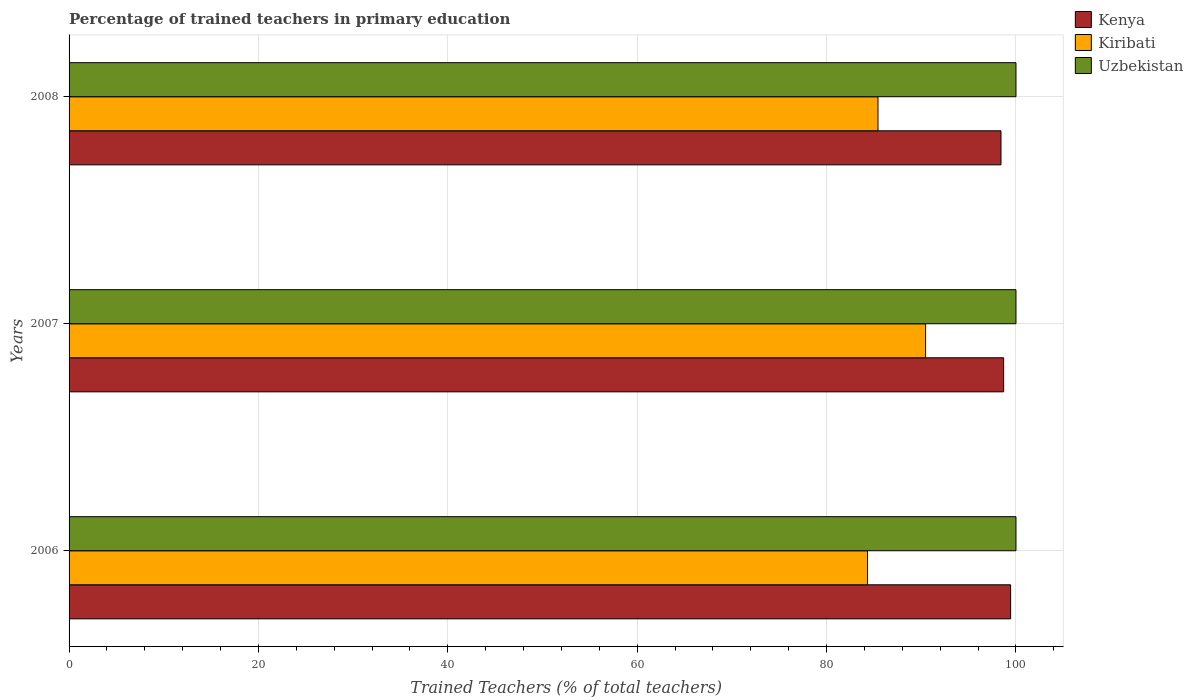Are the number of bars on each tick of the Y-axis equal?
Offer a terse response. Yes. What is the label of the 3rd group of bars from the top?
Offer a terse response. 2006. In how many cases, is the number of bars for a given year not equal to the number of legend labels?
Your answer should be compact. 0. What is the percentage of trained teachers in Kenya in 2006?
Make the answer very short. 99.43. Across all years, what is the minimum percentage of trained teachers in Uzbekistan?
Offer a very short reply. 100. In which year was the percentage of trained teachers in Kenya maximum?
Provide a succinct answer. 2006. In which year was the percentage of trained teachers in Uzbekistan minimum?
Your answer should be compact. 2006. What is the total percentage of trained teachers in Uzbekistan in the graph?
Keep it short and to the point. 300. What is the difference between the percentage of trained teachers in Kiribati in 2006 and the percentage of trained teachers in Uzbekistan in 2008?
Your response must be concise. -15.68. In the year 2007, what is the difference between the percentage of trained teachers in Uzbekistan and percentage of trained teachers in Kiribati?
Your answer should be very brief. 9.55. In how many years, is the percentage of trained teachers in Kiribati greater than 48 %?
Offer a very short reply. 3. What is the ratio of the percentage of trained teachers in Kenya in 2006 to that in 2008?
Provide a succinct answer. 1.01. Is the percentage of trained teachers in Kenya in 2006 less than that in 2008?
Offer a terse response. No. What is the difference between the highest and the second highest percentage of trained teachers in Kiribati?
Provide a short and direct response. 5.03. What is the difference between the highest and the lowest percentage of trained teachers in Uzbekistan?
Provide a short and direct response. 0. What does the 3rd bar from the top in 2008 represents?
Provide a succinct answer. Kenya. What does the 1st bar from the bottom in 2008 represents?
Your response must be concise. Kenya. Is it the case that in every year, the sum of the percentage of trained teachers in Uzbekistan and percentage of trained teachers in Kenya is greater than the percentage of trained teachers in Kiribati?
Your response must be concise. Yes. How many bars are there?
Make the answer very short. 9. Are all the bars in the graph horizontal?
Offer a terse response. Yes. Does the graph contain any zero values?
Offer a very short reply. No. Does the graph contain grids?
Provide a succinct answer. Yes. Where does the legend appear in the graph?
Offer a very short reply. Top right. How many legend labels are there?
Your answer should be compact. 3. How are the legend labels stacked?
Make the answer very short. Vertical. What is the title of the graph?
Keep it short and to the point. Percentage of trained teachers in primary education. What is the label or title of the X-axis?
Offer a very short reply. Trained Teachers (% of total teachers). What is the label or title of the Y-axis?
Your answer should be compact. Years. What is the Trained Teachers (% of total teachers) in Kenya in 2006?
Give a very brief answer. 99.43. What is the Trained Teachers (% of total teachers) of Kiribati in 2006?
Your response must be concise. 84.32. What is the Trained Teachers (% of total teachers) in Kenya in 2007?
Give a very brief answer. 98.7. What is the Trained Teachers (% of total teachers) of Kiribati in 2007?
Your answer should be compact. 90.45. What is the Trained Teachers (% of total teachers) of Uzbekistan in 2007?
Offer a very short reply. 100. What is the Trained Teachers (% of total teachers) in Kenya in 2008?
Make the answer very short. 98.42. What is the Trained Teachers (% of total teachers) of Kiribati in 2008?
Your answer should be compact. 85.43. What is the Trained Teachers (% of total teachers) of Uzbekistan in 2008?
Your answer should be very brief. 100. Across all years, what is the maximum Trained Teachers (% of total teachers) in Kenya?
Offer a terse response. 99.43. Across all years, what is the maximum Trained Teachers (% of total teachers) of Kiribati?
Ensure brevity in your answer.  90.45. Across all years, what is the maximum Trained Teachers (% of total teachers) in Uzbekistan?
Provide a succinct answer. 100. Across all years, what is the minimum Trained Teachers (% of total teachers) of Kenya?
Your answer should be very brief. 98.42. Across all years, what is the minimum Trained Teachers (% of total teachers) in Kiribati?
Keep it short and to the point. 84.32. What is the total Trained Teachers (% of total teachers) in Kenya in the graph?
Provide a short and direct response. 296.55. What is the total Trained Teachers (% of total teachers) of Kiribati in the graph?
Ensure brevity in your answer.  260.2. What is the total Trained Teachers (% of total teachers) in Uzbekistan in the graph?
Provide a succinct answer. 300. What is the difference between the Trained Teachers (% of total teachers) in Kenya in 2006 and that in 2007?
Provide a short and direct response. 0.74. What is the difference between the Trained Teachers (% of total teachers) in Kiribati in 2006 and that in 2007?
Offer a very short reply. -6.13. What is the difference between the Trained Teachers (% of total teachers) of Uzbekistan in 2006 and that in 2007?
Your response must be concise. 0. What is the difference between the Trained Teachers (% of total teachers) in Kenya in 2006 and that in 2008?
Offer a very short reply. 1.02. What is the difference between the Trained Teachers (% of total teachers) of Kiribati in 2006 and that in 2008?
Your answer should be very brief. -1.1. What is the difference between the Trained Teachers (% of total teachers) of Kenya in 2007 and that in 2008?
Your response must be concise. 0.28. What is the difference between the Trained Teachers (% of total teachers) of Kiribati in 2007 and that in 2008?
Give a very brief answer. 5.03. What is the difference between the Trained Teachers (% of total teachers) in Kenya in 2006 and the Trained Teachers (% of total teachers) in Kiribati in 2007?
Provide a succinct answer. 8.98. What is the difference between the Trained Teachers (% of total teachers) of Kenya in 2006 and the Trained Teachers (% of total teachers) of Uzbekistan in 2007?
Ensure brevity in your answer.  -0.57. What is the difference between the Trained Teachers (% of total teachers) in Kiribati in 2006 and the Trained Teachers (% of total teachers) in Uzbekistan in 2007?
Your answer should be compact. -15.68. What is the difference between the Trained Teachers (% of total teachers) in Kenya in 2006 and the Trained Teachers (% of total teachers) in Kiribati in 2008?
Provide a short and direct response. 14.01. What is the difference between the Trained Teachers (% of total teachers) of Kenya in 2006 and the Trained Teachers (% of total teachers) of Uzbekistan in 2008?
Provide a succinct answer. -0.57. What is the difference between the Trained Teachers (% of total teachers) of Kiribati in 2006 and the Trained Teachers (% of total teachers) of Uzbekistan in 2008?
Give a very brief answer. -15.68. What is the difference between the Trained Teachers (% of total teachers) in Kenya in 2007 and the Trained Teachers (% of total teachers) in Kiribati in 2008?
Provide a succinct answer. 13.27. What is the difference between the Trained Teachers (% of total teachers) in Kenya in 2007 and the Trained Teachers (% of total teachers) in Uzbekistan in 2008?
Offer a very short reply. -1.3. What is the difference between the Trained Teachers (% of total teachers) in Kiribati in 2007 and the Trained Teachers (% of total teachers) in Uzbekistan in 2008?
Your response must be concise. -9.55. What is the average Trained Teachers (% of total teachers) of Kenya per year?
Make the answer very short. 98.85. What is the average Trained Teachers (% of total teachers) of Kiribati per year?
Your answer should be very brief. 86.73. What is the average Trained Teachers (% of total teachers) of Uzbekistan per year?
Ensure brevity in your answer.  100. In the year 2006, what is the difference between the Trained Teachers (% of total teachers) in Kenya and Trained Teachers (% of total teachers) in Kiribati?
Ensure brevity in your answer.  15.11. In the year 2006, what is the difference between the Trained Teachers (% of total teachers) in Kenya and Trained Teachers (% of total teachers) in Uzbekistan?
Offer a terse response. -0.57. In the year 2006, what is the difference between the Trained Teachers (% of total teachers) of Kiribati and Trained Teachers (% of total teachers) of Uzbekistan?
Provide a succinct answer. -15.68. In the year 2007, what is the difference between the Trained Teachers (% of total teachers) in Kenya and Trained Teachers (% of total teachers) in Kiribati?
Offer a very short reply. 8.24. In the year 2007, what is the difference between the Trained Teachers (% of total teachers) in Kenya and Trained Teachers (% of total teachers) in Uzbekistan?
Provide a short and direct response. -1.3. In the year 2007, what is the difference between the Trained Teachers (% of total teachers) in Kiribati and Trained Teachers (% of total teachers) in Uzbekistan?
Your answer should be compact. -9.55. In the year 2008, what is the difference between the Trained Teachers (% of total teachers) in Kenya and Trained Teachers (% of total teachers) in Kiribati?
Keep it short and to the point. 12.99. In the year 2008, what is the difference between the Trained Teachers (% of total teachers) of Kenya and Trained Teachers (% of total teachers) of Uzbekistan?
Your response must be concise. -1.58. In the year 2008, what is the difference between the Trained Teachers (% of total teachers) of Kiribati and Trained Teachers (% of total teachers) of Uzbekistan?
Provide a succinct answer. -14.57. What is the ratio of the Trained Teachers (% of total teachers) in Kenya in 2006 to that in 2007?
Provide a short and direct response. 1.01. What is the ratio of the Trained Teachers (% of total teachers) of Kiribati in 2006 to that in 2007?
Your answer should be compact. 0.93. What is the ratio of the Trained Teachers (% of total teachers) in Uzbekistan in 2006 to that in 2007?
Keep it short and to the point. 1. What is the ratio of the Trained Teachers (% of total teachers) of Kenya in 2006 to that in 2008?
Provide a short and direct response. 1.01. What is the ratio of the Trained Teachers (% of total teachers) in Kiribati in 2006 to that in 2008?
Provide a succinct answer. 0.99. What is the ratio of the Trained Teachers (% of total teachers) of Uzbekistan in 2006 to that in 2008?
Provide a succinct answer. 1. What is the ratio of the Trained Teachers (% of total teachers) in Kenya in 2007 to that in 2008?
Keep it short and to the point. 1. What is the ratio of the Trained Teachers (% of total teachers) of Kiribati in 2007 to that in 2008?
Your response must be concise. 1.06. What is the ratio of the Trained Teachers (% of total teachers) in Uzbekistan in 2007 to that in 2008?
Offer a terse response. 1. What is the difference between the highest and the second highest Trained Teachers (% of total teachers) in Kenya?
Provide a succinct answer. 0.74. What is the difference between the highest and the second highest Trained Teachers (% of total teachers) of Kiribati?
Provide a short and direct response. 5.03. What is the difference between the highest and the lowest Trained Teachers (% of total teachers) of Kenya?
Provide a short and direct response. 1.02. What is the difference between the highest and the lowest Trained Teachers (% of total teachers) in Kiribati?
Your answer should be compact. 6.13. 